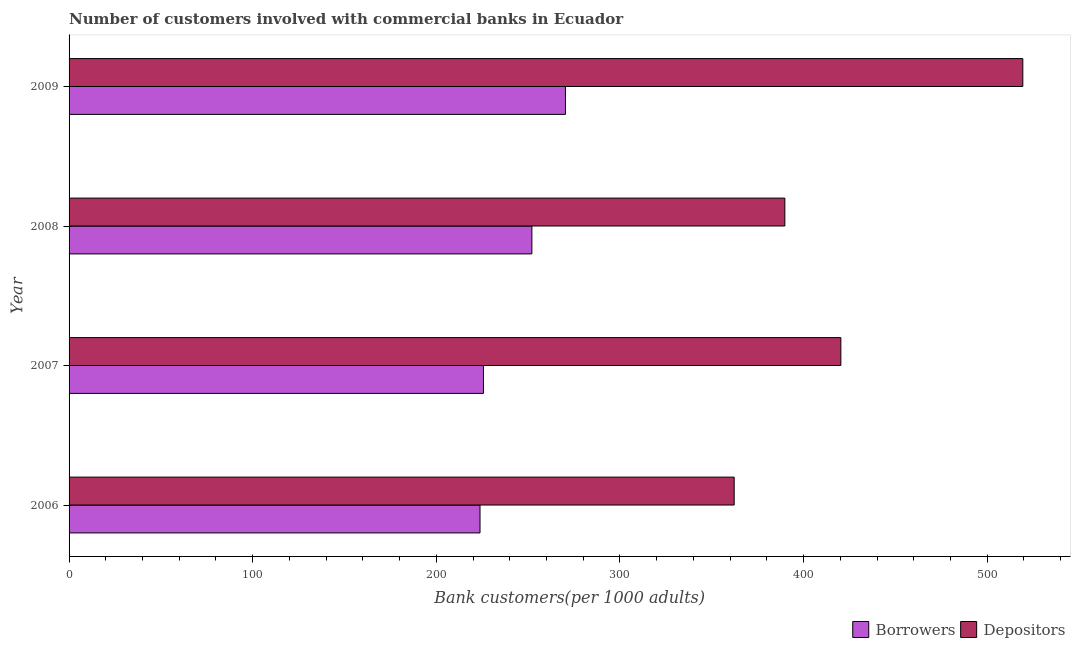How many different coloured bars are there?
Give a very brief answer. 2. Are the number of bars per tick equal to the number of legend labels?
Offer a very short reply. Yes. Are the number of bars on each tick of the Y-axis equal?
Your answer should be compact. Yes. How many bars are there on the 2nd tick from the bottom?
Make the answer very short. 2. What is the label of the 2nd group of bars from the top?
Offer a very short reply. 2008. What is the number of borrowers in 2009?
Your response must be concise. 270.31. Across all years, what is the maximum number of borrowers?
Keep it short and to the point. 270.31. Across all years, what is the minimum number of depositors?
Provide a short and direct response. 362.19. In which year was the number of borrowers maximum?
Make the answer very short. 2009. What is the total number of borrowers in the graph?
Provide a succinct answer. 971.77. What is the difference between the number of depositors in 2007 and that in 2009?
Provide a succinct answer. -99.08. What is the difference between the number of borrowers in 2009 and the number of depositors in 2006?
Ensure brevity in your answer.  -91.88. What is the average number of borrowers per year?
Ensure brevity in your answer.  242.94. In the year 2008, what is the difference between the number of depositors and number of borrowers?
Your answer should be very brief. 137.76. What is the ratio of the number of depositors in 2006 to that in 2008?
Provide a succinct answer. 0.93. Is the difference between the number of depositors in 2007 and 2008 greater than the difference between the number of borrowers in 2007 and 2008?
Give a very brief answer. Yes. What is the difference between the highest and the second highest number of depositors?
Your answer should be very brief. 99.08. What is the difference between the highest and the lowest number of borrowers?
Your answer should be compact. 46.52. In how many years, is the number of depositors greater than the average number of depositors taken over all years?
Offer a very short reply. 1. What does the 2nd bar from the top in 2009 represents?
Offer a very short reply. Borrowers. What does the 1st bar from the bottom in 2009 represents?
Give a very brief answer. Borrowers. How many bars are there?
Provide a short and direct response. 8. Are the values on the major ticks of X-axis written in scientific E-notation?
Your response must be concise. No. Does the graph contain any zero values?
Offer a terse response. No. Where does the legend appear in the graph?
Keep it short and to the point. Bottom right. How many legend labels are there?
Keep it short and to the point. 2. How are the legend labels stacked?
Provide a succinct answer. Horizontal. What is the title of the graph?
Ensure brevity in your answer.  Number of customers involved with commercial banks in Ecuador. Does "Male entrants" appear as one of the legend labels in the graph?
Your response must be concise. No. What is the label or title of the X-axis?
Give a very brief answer. Bank customers(per 1000 adults). What is the label or title of the Y-axis?
Your response must be concise. Year. What is the Bank customers(per 1000 adults) in Borrowers in 2006?
Your answer should be compact. 223.79. What is the Bank customers(per 1000 adults) of Depositors in 2006?
Offer a very short reply. 362.19. What is the Bank customers(per 1000 adults) of Borrowers in 2007?
Ensure brevity in your answer.  225.65. What is the Bank customers(per 1000 adults) of Depositors in 2007?
Your response must be concise. 420.28. What is the Bank customers(per 1000 adults) of Borrowers in 2008?
Provide a succinct answer. 252.02. What is the Bank customers(per 1000 adults) in Depositors in 2008?
Provide a succinct answer. 389.78. What is the Bank customers(per 1000 adults) in Borrowers in 2009?
Provide a short and direct response. 270.31. What is the Bank customers(per 1000 adults) of Depositors in 2009?
Your answer should be very brief. 519.36. Across all years, what is the maximum Bank customers(per 1000 adults) in Borrowers?
Offer a very short reply. 270.31. Across all years, what is the maximum Bank customers(per 1000 adults) in Depositors?
Provide a succinct answer. 519.36. Across all years, what is the minimum Bank customers(per 1000 adults) in Borrowers?
Your response must be concise. 223.79. Across all years, what is the minimum Bank customers(per 1000 adults) of Depositors?
Your answer should be very brief. 362.19. What is the total Bank customers(per 1000 adults) of Borrowers in the graph?
Make the answer very short. 971.77. What is the total Bank customers(per 1000 adults) in Depositors in the graph?
Provide a succinct answer. 1691.61. What is the difference between the Bank customers(per 1000 adults) of Borrowers in 2006 and that in 2007?
Your answer should be very brief. -1.87. What is the difference between the Bank customers(per 1000 adults) of Depositors in 2006 and that in 2007?
Ensure brevity in your answer.  -58.09. What is the difference between the Bank customers(per 1000 adults) of Borrowers in 2006 and that in 2008?
Provide a succinct answer. -28.24. What is the difference between the Bank customers(per 1000 adults) of Depositors in 2006 and that in 2008?
Offer a terse response. -27.6. What is the difference between the Bank customers(per 1000 adults) in Borrowers in 2006 and that in 2009?
Offer a very short reply. -46.52. What is the difference between the Bank customers(per 1000 adults) in Depositors in 2006 and that in 2009?
Your response must be concise. -157.18. What is the difference between the Bank customers(per 1000 adults) in Borrowers in 2007 and that in 2008?
Offer a very short reply. -26.37. What is the difference between the Bank customers(per 1000 adults) of Depositors in 2007 and that in 2008?
Your answer should be compact. 30.5. What is the difference between the Bank customers(per 1000 adults) of Borrowers in 2007 and that in 2009?
Offer a terse response. -44.66. What is the difference between the Bank customers(per 1000 adults) in Depositors in 2007 and that in 2009?
Offer a very short reply. -99.08. What is the difference between the Bank customers(per 1000 adults) in Borrowers in 2008 and that in 2009?
Your answer should be compact. -18.29. What is the difference between the Bank customers(per 1000 adults) in Depositors in 2008 and that in 2009?
Provide a short and direct response. -129.58. What is the difference between the Bank customers(per 1000 adults) in Borrowers in 2006 and the Bank customers(per 1000 adults) in Depositors in 2007?
Keep it short and to the point. -196.49. What is the difference between the Bank customers(per 1000 adults) in Borrowers in 2006 and the Bank customers(per 1000 adults) in Depositors in 2008?
Make the answer very short. -166. What is the difference between the Bank customers(per 1000 adults) in Borrowers in 2006 and the Bank customers(per 1000 adults) in Depositors in 2009?
Ensure brevity in your answer.  -295.58. What is the difference between the Bank customers(per 1000 adults) in Borrowers in 2007 and the Bank customers(per 1000 adults) in Depositors in 2008?
Provide a short and direct response. -164.13. What is the difference between the Bank customers(per 1000 adults) of Borrowers in 2007 and the Bank customers(per 1000 adults) of Depositors in 2009?
Give a very brief answer. -293.71. What is the difference between the Bank customers(per 1000 adults) in Borrowers in 2008 and the Bank customers(per 1000 adults) in Depositors in 2009?
Offer a very short reply. -267.34. What is the average Bank customers(per 1000 adults) in Borrowers per year?
Provide a succinct answer. 242.94. What is the average Bank customers(per 1000 adults) of Depositors per year?
Offer a terse response. 422.9. In the year 2006, what is the difference between the Bank customers(per 1000 adults) of Borrowers and Bank customers(per 1000 adults) of Depositors?
Your answer should be very brief. -138.4. In the year 2007, what is the difference between the Bank customers(per 1000 adults) of Borrowers and Bank customers(per 1000 adults) of Depositors?
Make the answer very short. -194.63. In the year 2008, what is the difference between the Bank customers(per 1000 adults) in Borrowers and Bank customers(per 1000 adults) in Depositors?
Offer a terse response. -137.76. In the year 2009, what is the difference between the Bank customers(per 1000 adults) of Borrowers and Bank customers(per 1000 adults) of Depositors?
Offer a very short reply. -249.05. What is the ratio of the Bank customers(per 1000 adults) in Borrowers in 2006 to that in 2007?
Offer a very short reply. 0.99. What is the ratio of the Bank customers(per 1000 adults) in Depositors in 2006 to that in 2007?
Give a very brief answer. 0.86. What is the ratio of the Bank customers(per 1000 adults) of Borrowers in 2006 to that in 2008?
Give a very brief answer. 0.89. What is the ratio of the Bank customers(per 1000 adults) of Depositors in 2006 to that in 2008?
Keep it short and to the point. 0.93. What is the ratio of the Bank customers(per 1000 adults) in Borrowers in 2006 to that in 2009?
Keep it short and to the point. 0.83. What is the ratio of the Bank customers(per 1000 adults) of Depositors in 2006 to that in 2009?
Give a very brief answer. 0.7. What is the ratio of the Bank customers(per 1000 adults) in Borrowers in 2007 to that in 2008?
Your answer should be compact. 0.9. What is the ratio of the Bank customers(per 1000 adults) of Depositors in 2007 to that in 2008?
Your response must be concise. 1.08. What is the ratio of the Bank customers(per 1000 adults) of Borrowers in 2007 to that in 2009?
Ensure brevity in your answer.  0.83. What is the ratio of the Bank customers(per 1000 adults) in Depositors in 2007 to that in 2009?
Provide a succinct answer. 0.81. What is the ratio of the Bank customers(per 1000 adults) in Borrowers in 2008 to that in 2009?
Your response must be concise. 0.93. What is the ratio of the Bank customers(per 1000 adults) of Depositors in 2008 to that in 2009?
Your answer should be compact. 0.75. What is the difference between the highest and the second highest Bank customers(per 1000 adults) in Borrowers?
Make the answer very short. 18.29. What is the difference between the highest and the second highest Bank customers(per 1000 adults) in Depositors?
Provide a succinct answer. 99.08. What is the difference between the highest and the lowest Bank customers(per 1000 adults) of Borrowers?
Ensure brevity in your answer.  46.52. What is the difference between the highest and the lowest Bank customers(per 1000 adults) in Depositors?
Provide a short and direct response. 157.18. 